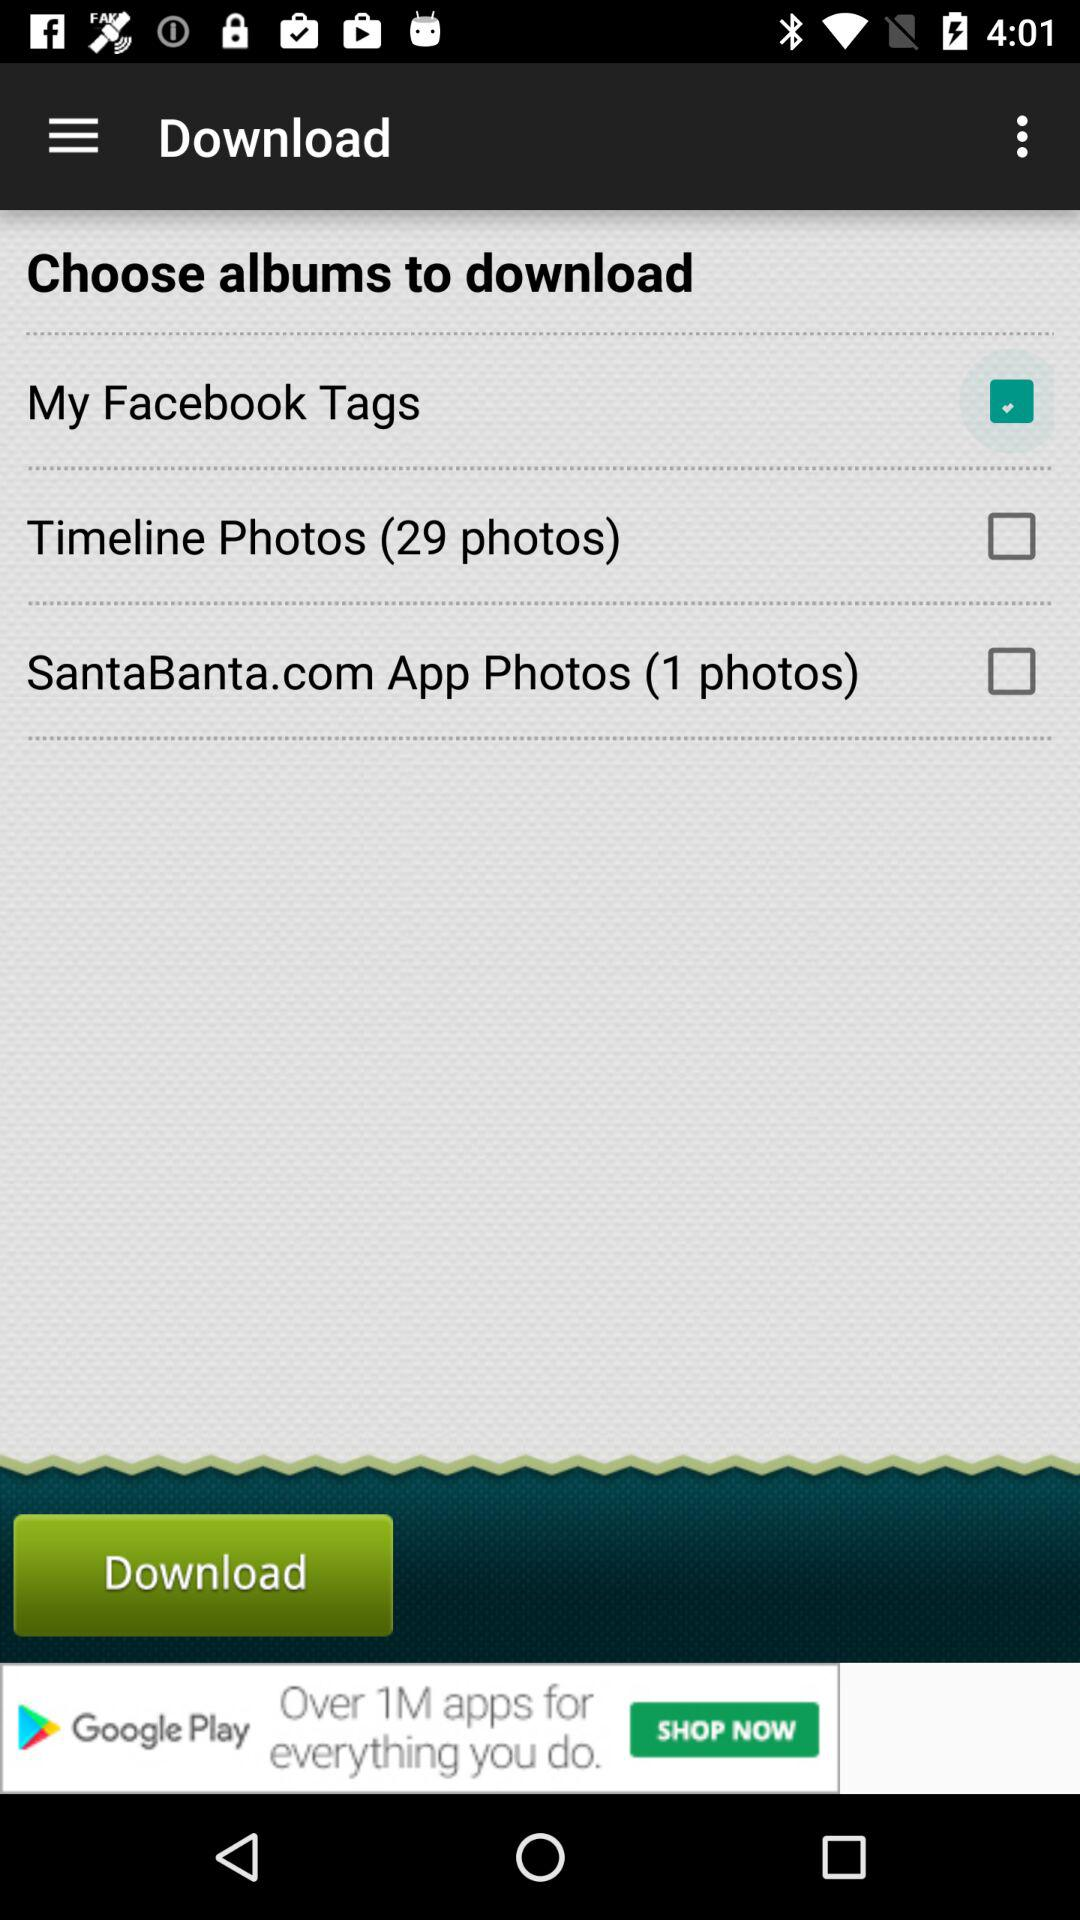How many photos are there in the timeline photos option? There are 29 photos in the timeline photos option. 